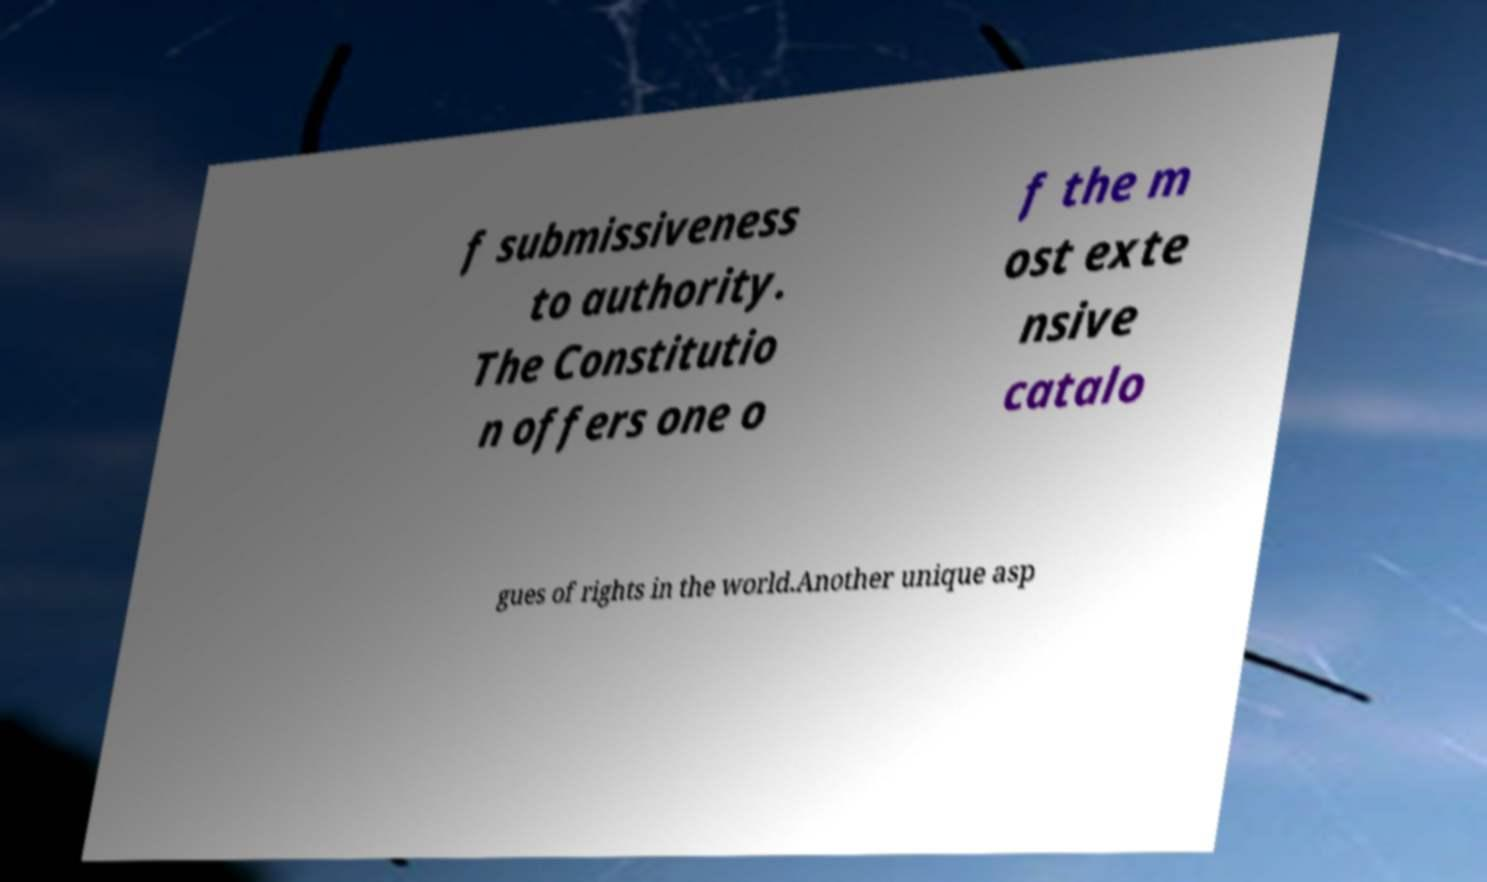Please read and relay the text visible in this image. What does it say? f submissiveness to authority. The Constitutio n offers one o f the m ost exte nsive catalo gues of rights in the world.Another unique asp 